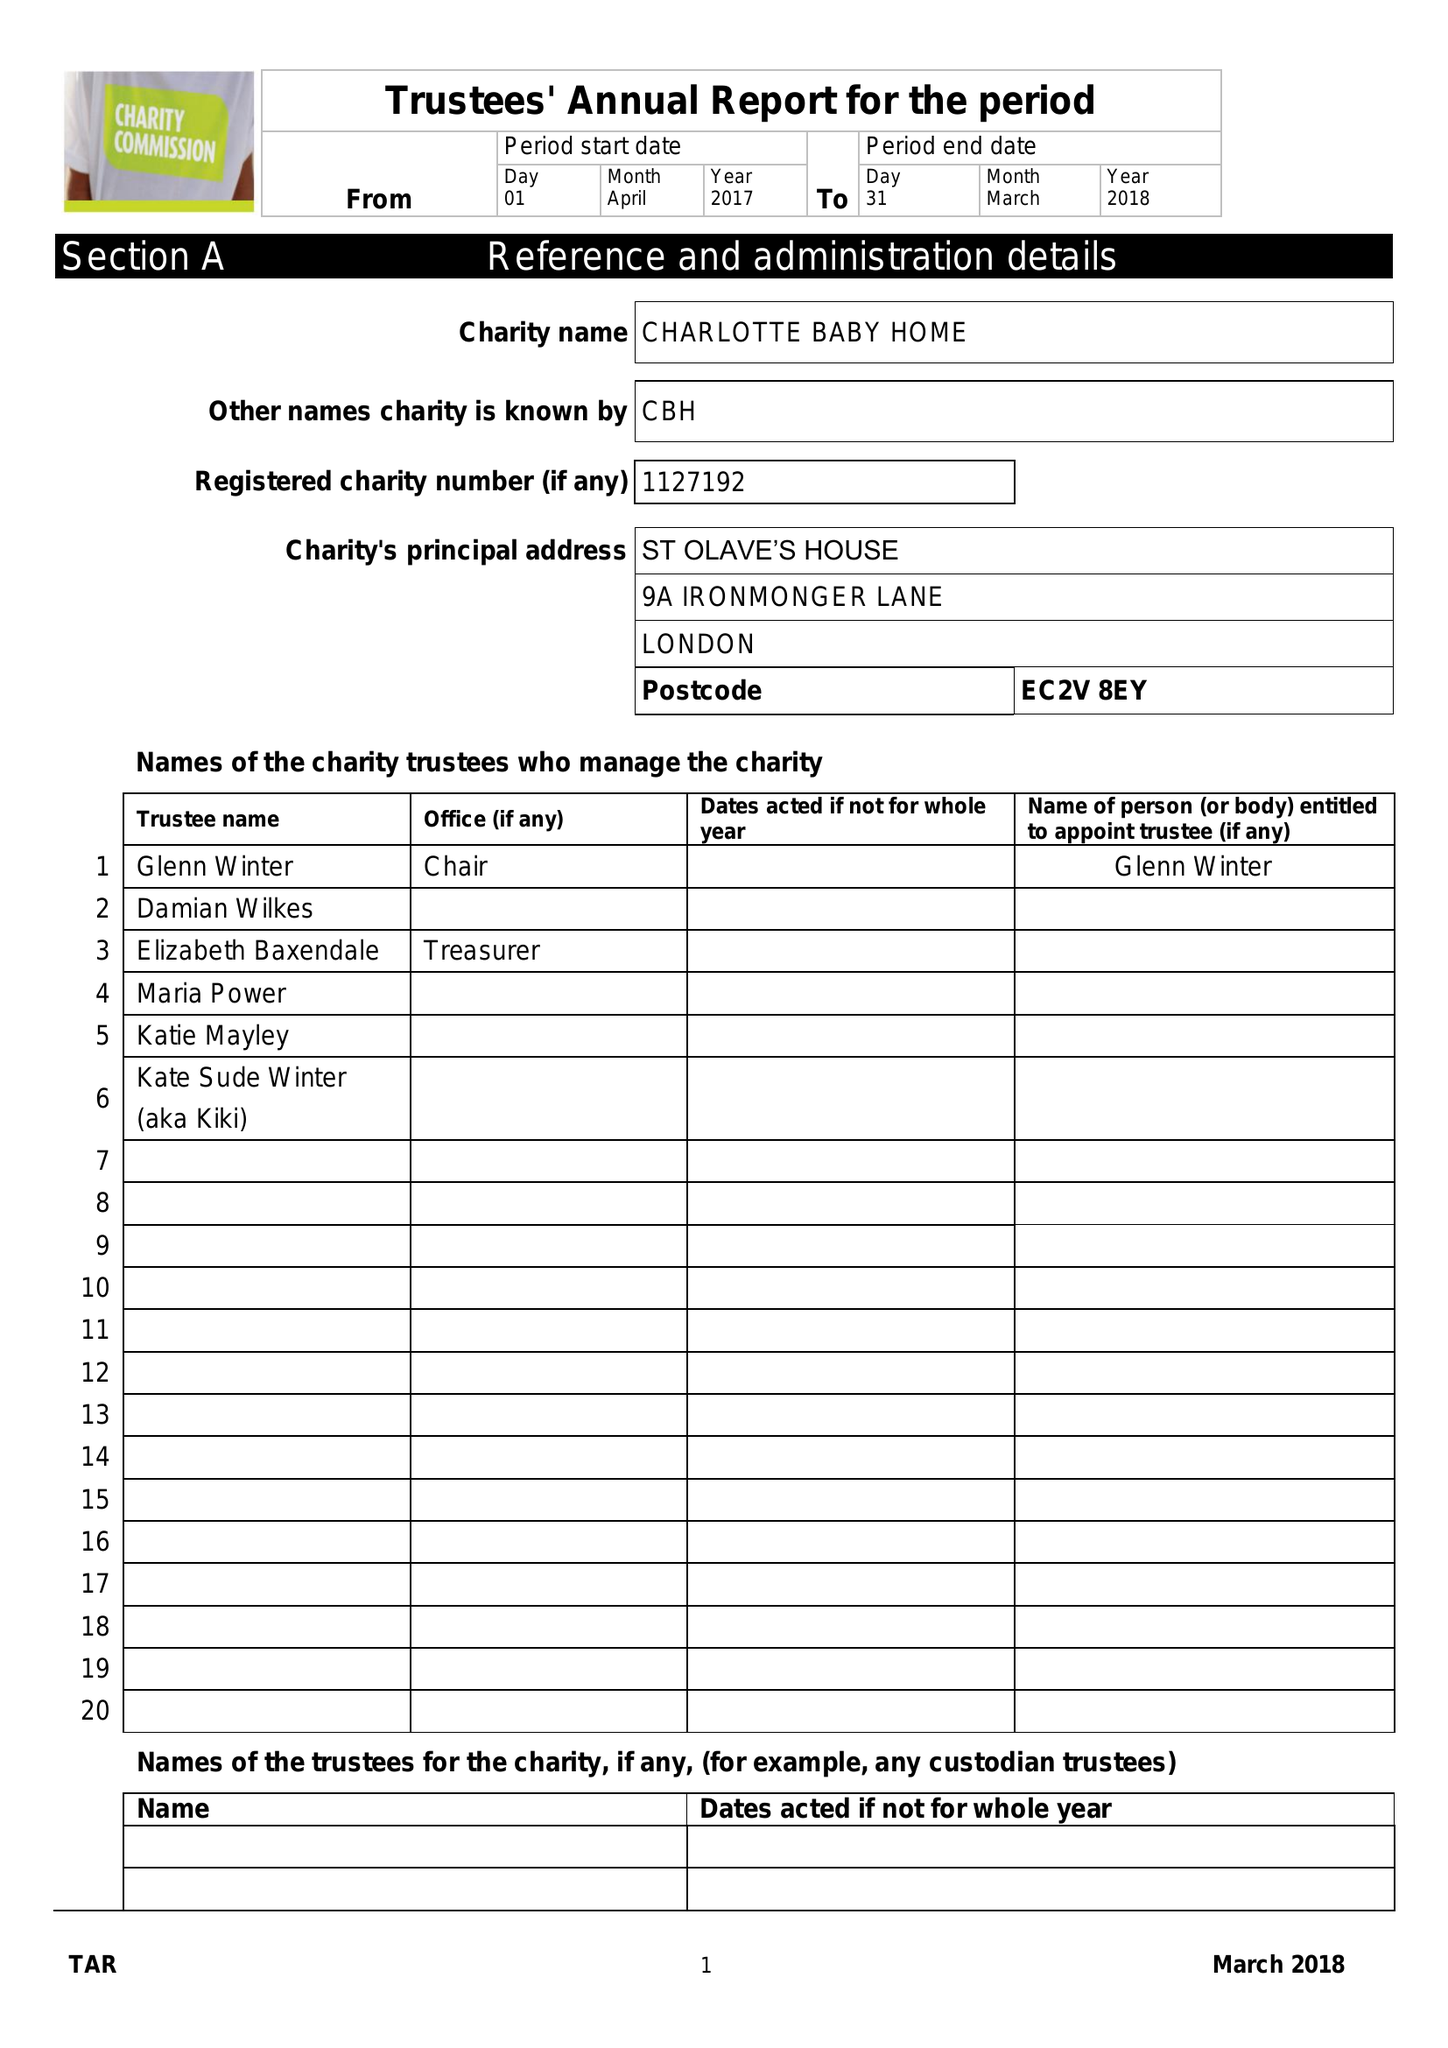What is the value for the income_annually_in_british_pounds?
Answer the question using a single word or phrase. 43412.00 